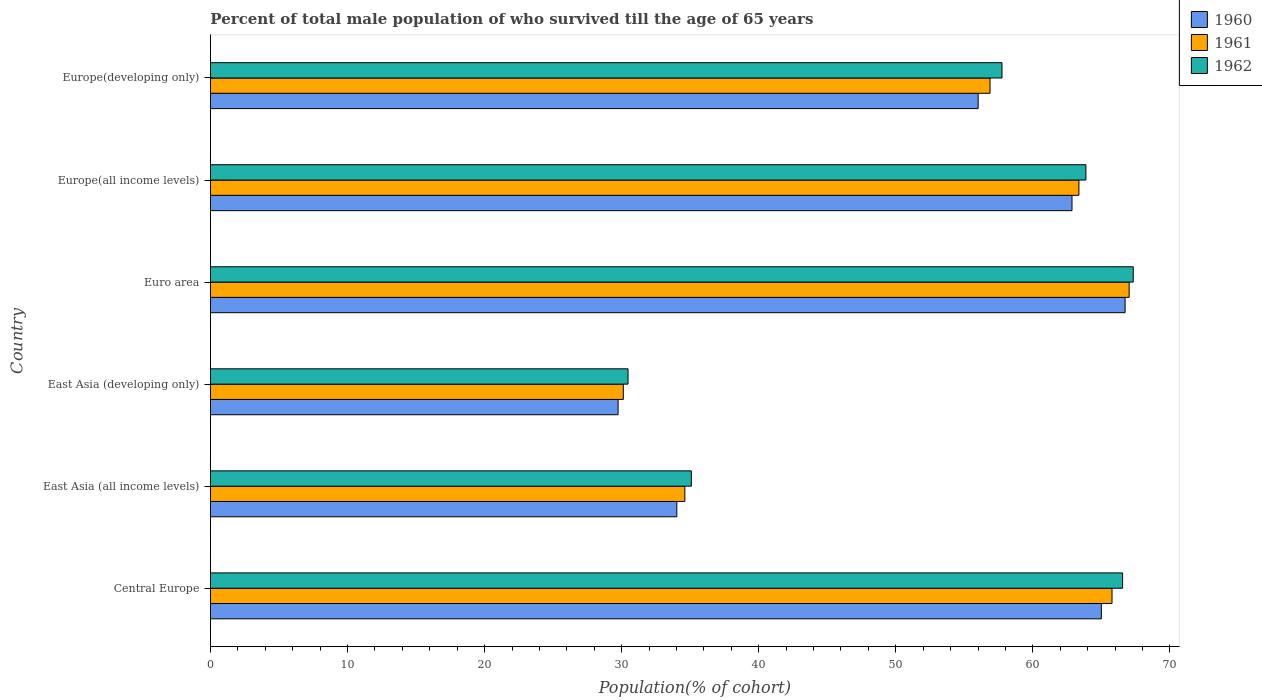How many different coloured bars are there?
Provide a short and direct response. 3. How many bars are there on the 2nd tick from the top?
Make the answer very short. 3. What is the label of the 4th group of bars from the top?
Your answer should be compact. East Asia (developing only). What is the percentage of total male population who survived till the age of 65 years in 1962 in East Asia (all income levels)?
Give a very brief answer. 35.08. Across all countries, what is the maximum percentage of total male population who survived till the age of 65 years in 1960?
Provide a short and direct response. 66.73. Across all countries, what is the minimum percentage of total male population who survived till the age of 65 years in 1962?
Your answer should be compact. 30.46. In which country was the percentage of total male population who survived till the age of 65 years in 1961 maximum?
Your answer should be compact. Euro area. In which country was the percentage of total male population who survived till the age of 65 years in 1961 minimum?
Make the answer very short. East Asia (developing only). What is the total percentage of total male population who survived till the age of 65 years in 1962 in the graph?
Offer a terse response. 321.03. What is the difference between the percentage of total male population who survived till the age of 65 years in 1962 in East Asia (all income levels) and that in Europe(developing only)?
Ensure brevity in your answer.  -22.67. What is the difference between the percentage of total male population who survived till the age of 65 years in 1962 in Europe(developing only) and the percentage of total male population who survived till the age of 65 years in 1960 in East Asia (developing only)?
Your answer should be compact. 28.01. What is the average percentage of total male population who survived till the age of 65 years in 1961 per country?
Provide a short and direct response. 52.96. What is the difference between the percentage of total male population who survived till the age of 65 years in 1960 and percentage of total male population who survived till the age of 65 years in 1961 in Euro area?
Provide a short and direct response. -0.3. In how many countries, is the percentage of total male population who survived till the age of 65 years in 1962 greater than 62 %?
Give a very brief answer. 3. What is the ratio of the percentage of total male population who survived till the age of 65 years in 1962 in Central Europe to that in Euro area?
Give a very brief answer. 0.99. Is the difference between the percentage of total male population who survived till the age of 65 years in 1960 in Euro area and Europe(developing only) greater than the difference between the percentage of total male population who survived till the age of 65 years in 1961 in Euro area and Europe(developing only)?
Keep it short and to the point. Yes. What is the difference between the highest and the second highest percentage of total male population who survived till the age of 65 years in 1962?
Offer a very short reply. 0.77. What is the difference between the highest and the lowest percentage of total male population who survived till the age of 65 years in 1960?
Give a very brief answer. 36.99. Is it the case that in every country, the sum of the percentage of total male population who survived till the age of 65 years in 1960 and percentage of total male population who survived till the age of 65 years in 1961 is greater than the percentage of total male population who survived till the age of 65 years in 1962?
Your answer should be compact. Yes. Are all the bars in the graph horizontal?
Offer a very short reply. Yes. How many countries are there in the graph?
Give a very brief answer. 6. How are the legend labels stacked?
Offer a terse response. Vertical. What is the title of the graph?
Make the answer very short. Percent of total male population of who survived till the age of 65 years. What is the label or title of the X-axis?
Provide a succinct answer. Population(% of cohort). What is the label or title of the Y-axis?
Provide a succinct answer. Country. What is the Population(% of cohort) of 1960 in Central Europe?
Provide a short and direct response. 65. What is the Population(% of cohort) of 1961 in Central Europe?
Offer a very short reply. 65.77. What is the Population(% of cohort) in 1962 in Central Europe?
Keep it short and to the point. 66.55. What is the Population(% of cohort) of 1960 in East Asia (all income levels)?
Make the answer very short. 34.02. What is the Population(% of cohort) in 1961 in East Asia (all income levels)?
Provide a succinct answer. 34.61. What is the Population(% of cohort) in 1962 in East Asia (all income levels)?
Offer a terse response. 35.08. What is the Population(% of cohort) of 1960 in East Asia (developing only)?
Make the answer very short. 29.74. What is the Population(% of cohort) in 1961 in East Asia (developing only)?
Keep it short and to the point. 30.12. What is the Population(% of cohort) of 1962 in East Asia (developing only)?
Give a very brief answer. 30.46. What is the Population(% of cohort) of 1960 in Euro area?
Offer a very short reply. 66.73. What is the Population(% of cohort) of 1961 in Euro area?
Give a very brief answer. 67.03. What is the Population(% of cohort) in 1962 in Euro area?
Provide a short and direct response. 67.32. What is the Population(% of cohort) in 1960 in Europe(all income levels)?
Provide a succinct answer. 62.85. What is the Population(% of cohort) in 1961 in Europe(all income levels)?
Offer a terse response. 63.36. What is the Population(% of cohort) in 1962 in Europe(all income levels)?
Your answer should be compact. 63.87. What is the Population(% of cohort) of 1960 in Europe(developing only)?
Give a very brief answer. 56.01. What is the Population(% of cohort) in 1961 in Europe(developing only)?
Your response must be concise. 56.88. What is the Population(% of cohort) of 1962 in Europe(developing only)?
Your response must be concise. 57.75. Across all countries, what is the maximum Population(% of cohort) of 1960?
Provide a short and direct response. 66.73. Across all countries, what is the maximum Population(% of cohort) of 1961?
Give a very brief answer. 67.03. Across all countries, what is the maximum Population(% of cohort) of 1962?
Give a very brief answer. 67.32. Across all countries, what is the minimum Population(% of cohort) in 1960?
Make the answer very short. 29.74. Across all countries, what is the minimum Population(% of cohort) in 1961?
Make the answer very short. 30.12. Across all countries, what is the minimum Population(% of cohort) in 1962?
Make the answer very short. 30.46. What is the total Population(% of cohort) in 1960 in the graph?
Your response must be concise. 314.35. What is the total Population(% of cohort) of 1961 in the graph?
Make the answer very short. 317.76. What is the total Population(% of cohort) in 1962 in the graph?
Provide a succinct answer. 321.03. What is the difference between the Population(% of cohort) of 1960 in Central Europe and that in East Asia (all income levels)?
Keep it short and to the point. 30.97. What is the difference between the Population(% of cohort) of 1961 in Central Europe and that in East Asia (all income levels)?
Offer a terse response. 31.17. What is the difference between the Population(% of cohort) of 1962 in Central Europe and that in East Asia (all income levels)?
Provide a short and direct response. 31.47. What is the difference between the Population(% of cohort) of 1960 in Central Europe and that in East Asia (developing only)?
Provide a short and direct response. 35.26. What is the difference between the Population(% of cohort) of 1961 in Central Europe and that in East Asia (developing only)?
Give a very brief answer. 35.65. What is the difference between the Population(% of cohort) of 1962 in Central Europe and that in East Asia (developing only)?
Your response must be concise. 36.08. What is the difference between the Population(% of cohort) in 1960 in Central Europe and that in Euro area?
Offer a very short reply. -1.73. What is the difference between the Population(% of cohort) of 1961 in Central Europe and that in Euro area?
Offer a very short reply. -1.25. What is the difference between the Population(% of cohort) of 1962 in Central Europe and that in Euro area?
Your response must be concise. -0.77. What is the difference between the Population(% of cohort) in 1960 in Central Europe and that in Europe(all income levels)?
Make the answer very short. 2.14. What is the difference between the Population(% of cohort) in 1961 in Central Europe and that in Europe(all income levels)?
Offer a very short reply. 2.41. What is the difference between the Population(% of cohort) in 1962 in Central Europe and that in Europe(all income levels)?
Provide a short and direct response. 2.68. What is the difference between the Population(% of cohort) in 1960 in Central Europe and that in Europe(developing only)?
Your answer should be compact. 8.99. What is the difference between the Population(% of cohort) of 1961 in Central Europe and that in Europe(developing only)?
Your response must be concise. 8.9. What is the difference between the Population(% of cohort) in 1962 in Central Europe and that in Europe(developing only)?
Keep it short and to the point. 8.8. What is the difference between the Population(% of cohort) in 1960 in East Asia (all income levels) and that in East Asia (developing only)?
Your response must be concise. 4.28. What is the difference between the Population(% of cohort) of 1961 in East Asia (all income levels) and that in East Asia (developing only)?
Keep it short and to the point. 4.49. What is the difference between the Population(% of cohort) of 1962 in East Asia (all income levels) and that in East Asia (developing only)?
Your response must be concise. 4.62. What is the difference between the Population(% of cohort) in 1960 in East Asia (all income levels) and that in Euro area?
Offer a very short reply. -32.71. What is the difference between the Population(% of cohort) in 1961 in East Asia (all income levels) and that in Euro area?
Offer a very short reply. -32.42. What is the difference between the Population(% of cohort) of 1962 in East Asia (all income levels) and that in Euro area?
Provide a succinct answer. -32.24. What is the difference between the Population(% of cohort) of 1960 in East Asia (all income levels) and that in Europe(all income levels)?
Your answer should be compact. -28.83. What is the difference between the Population(% of cohort) in 1961 in East Asia (all income levels) and that in Europe(all income levels)?
Your answer should be compact. -28.75. What is the difference between the Population(% of cohort) of 1962 in East Asia (all income levels) and that in Europe(all income levels)?
Provide a succinct answer. -28.79. What is the difference between the Population(% of cohort) of 1960 in East Asia (all income levels) and that in Europe(developing only)?
Keep it short and to the point. -21.98. What is the difference between the Population(% of cohort) of 1961 in East Asia (all income levels) and that in Europe(developing only)?
Your response must be concise. -22.27. What is the difference between the Population(% of cohort) of 1962 in East Asia (all income levels) and that in Europe(developing only)?
Your response must be concise. -22.67. What is the difference between the Population(% of cohort) of 1960 in East Asia (developing only) and that in Euro area?
Offer a very short reply. -36.99. What is the difference between the Population(% of cohort) in 1961 in East Asia (developing only) and that in Euro area?
Keep it short and to the point. -36.9. What is the difference between the Population(% of cohort) in 1962 in East Asia (developing only) and that in Euro area?
Provide a succinct answer. -36.86. What is the difference between the Population(% of cohort) in 1960 in East Asia (developing only) and that in Europe(all income levels)?
Make the answer very short. -33.12. What is the difference between the Population(% of cohort) of 1961 in East Asia (developing only) and that in Europe(all income levels)?
Provide a succinct answer. -33.24. What is the difference between the Population(% of cohort) of 1962 in East Asia (developing only) and that in Europe(all income levels)?
Your answer should be very brief. -33.4. What is the difference between the Population(% of cohort) in 1960 in East Asia (developing only) and that in Europe(developing only)?
Give a very brief answer. -26.27. What is the difference between the Population(% of cohort) of 1961 in East Asia (developing only) and that in Europe(developing only)?
Your response must be concise. -26.75. What is the difference between the Population(% of cohort) in 1962 in East Asia (developing only) and that in Europe(developing only)?
Offer a very short reply. -27.28. What is the difference between the Population(% of cohort) of 1960 in Euro area and that in Europe(all income levels)?
Your answer should be compact. 3.87. What is the difference between the Population(% of cohort) of 1961 in Euro area and that in Europe(all income levels)?
Offer a very short reply. 3.67. What is the difference between the Population(% of cohort) in 1962 in Euro area and that in Europe(all income levels)?
Your answer should be very brief. 3.45. What is the difference between the Population(% of cohort) in 1960 in Euro area and that in Europe(developing only)?
Keep it short and to the point. 10.72. What is the difference between the Population(% of cohort) in 1961 in Euro area and that in Europe(developing only)?
Make the answer very short. 10.15. What is the difference between the Population(% of cohort) of 1962 in Euro area and that in Europe(developing only)?
Keep it short and to the point. 9.57. What is the difference between the Population(% of cohort) of 1960 in Europe(all income levels) and that in Europe(developing only)?
Your response must be concise. 6.85. What is the difference between the Population(% of cohort) in 1961 in Europe(all income levels) and that in Europe(developing only)?
Your answer should be compact. 6.49. What is the difference between the Population(% of cohort) in 1962 in Europe(all income levels) and that in Europe(developing only)?
Your answer should be very brief. 6.12. What is the difference between the Population(% of cohort) of 1960 in Central Europe and the Population(% of cohort) of 1961 in East Asia (all income levels)?
Ensure brevity in your answer.  30.39. What is the difference between the Population(% of cohort) in 1960 in Central Europe and the Population(% of cohort) in 1962 in East Asia (all income levels)?
Keep it short and to the point. 29.91. What is the difference between the Population(% of cohort) of 1961 in Central Europe and the Population(% of cohort) of 1962 in East Asia (all income levels)?
Provide a succinct answer. 30.69. What is the difference between the Population(% of cohort) in 1960 in Central Europe and the Population(% of cohort) in 1961 in East Asia (developing only)?
Your answer should be very brief. 34.87. What is the difference between the Population(% of cohort) in 1960 in Central Europe and the Population(% of cohort) in 1962 in East Asia (developing only)?
Your answer should be very brief. 34.53. What is the difference between the Population(% of cohort) in 1961 in Central Europe and the Population(% of cohort) in 1962 in East Asia (developing only)?
Ensure brevity in your answer.  35.31. What is the difference between the Population(% of cohort) of 1960 in Central Europe and the Population(% of cohort) of 1961 in Euro area?
Provide a short and direct response. -2.03. What is the difference between the Population(% of cohort) of 1960 in Central Europe and the Population(% of cohort) of 1962 in Euro area?
Your answer should be very brief. -2.33. What is the difference between the Population(% of cohort) of 1961 in Central Europe and the Population(% of cohort) of 1962 in Euro area?
Provide a short and direct response. -1.55. What is the difference between the Population(% of cohort) of 1960 in Central Europe and the Population(% of cohort) of 1961 in Europe(all income levels)?
Your answer should be very brief. 1.64. What is the difference between the Population(% of cohort) in 1960 in Central Europe and the Population(% of cohort) in 1962 in Europe(all income levels)?
Provide a succinct answer. 1.13. What is the difference between the Population(% of cohort) of 1961 in Central Europe and the Population(% of cohort) of 1962 in Europe(all income levels)?
Ensure brevity in your answer.  1.91. What is the difference between the Population(% of cohort) in 1960 in Central Europe and the Population(% of cohort) in 1961 in Europe(developing only)?
Ensure brevity in your answer.  8.12. What is the difference between the Population(% of cohort) of 1960 in Central Europe and the Population(% of cohort) of 1962 in Europe(developing only)?
Offer a terse response. 7.25. What is the difference between the Population(% of cohort) in 1961 in Central Europe and the Population(% of cohort) in 1962 in Europe(developing only)?
Ensure brevity in your answer.  8.03. What is the difference between the Population(% of cohort) in 1960 in East Asia (all income levels) and the Population(% of cohort) in 1961 in East Asia (developing only)?
Make the answer very short. 3.9. What is the difference between the Population(% of cohort) of 1960 in East Asia (all income levels) and the Population(% of cohort) of 1962 in East Asia (developing only)?
Keep it short and to the point. 3.56. What is the difference between the Population(% of cohort) of 1961 in East Asia (all income levels) and the Population(% of cohort) of 1962 in East Asia (developing only)?
Your answer should be very brief. 4.14. What is the difference between the Population(% of cohort) in 1960 in East Asia (all income levels) and the Population(% of cohort) in 1961 in Euro area?
Provide a succinct answer. -33. What is the difference between the Population(% of cohort) of 1960 in East Asia (all income levels) and the Population(% of cohort) of 1962 in Euro area?
Give a very brief answer. -33.3. What is the difference between the Population(% of cohort) in 1961 in East Asia (all income levels) and the Population(% of cohort) in 1962 in Euro area?
Provide a short and direct response. -32.71. What is the difference between the Population(% of cohort) in 1960 in East Asia (all income levels) and the Population(% of cohort) in 1961 in Europe(all income levels)?
Make the answer very short. -29.34. What is the difference between the Population(% of cohort) in 1960 in East Asia (all income levels) and the Population(% of cohort) in 1962 in Europe(all income levels)?
Offer a terse response. -29.85. What is the difference between the Population(% of cohort) of 1961 in East Asia (all income levels) and the Population(% of cohort) of 1962 in Europe(all income levels)?
Ensure brevity in your answer.  -29.26. What is the difference between the Population(% of cohort) of 1960 in East Asia (all income levels) and the Population(% of cohort) of 1961 in Europe(developing only)?
Your response must be concise. -22.85. What is the difference between the Population(% of cohort) in 1960 in East Asia (all income levels) and the Population(% of cohort) in 1962 in Europe(developing only)?
Give a very brief answer. -23.72. What is the difference between the Population(% of cohort) in 1961 in East Asia (all income levels) and the Population(% of cohort) in 1962 in Europe(developing only)?
Your answer should be very brief. -23.14. What is the difference between the Population(% of cohort) in 1960 in East Asia (developing only) and the Population(% of cohort) in 1961 in Euro area?
Your response must be concise. -37.29. What is the difference between the Population(% of cohort) in 1960 in East Asia (developing only) and the Population(% of cohort) in 1962 in Euro area?
Make the answer very short. -37.58. What is the difference between the Population(% of cohort) in 1961 in East Asia (developing only) and the Population(% of cohort) in 1962 in Euro area?
Give a very brief answer. -37.2. What is the difference between the Population(% of cohort) of 1960 in East Asia (developing only) and the Population(% of cohort) of 1961 in Europe(all income levels)?
Provide a short and direct response. -33.62. What is the difference between the Population(% of cohort) of 1960 in East Asia (developing only) and the Population(% of cohort) of 1962 in Europe(all income levels)?
Provide a succinct answer. -34.13. What is the difference between the Population(% of cohort) in 1961 in East Asia (developing only) and the Population(% of cohort) in 1962 in Europe(all income levels)?
Provide a succinct answer. -33.75. What is the difference between the Population(% of cohort) of 1960 in East Asia (developing only) and the Population(% of cohort) of 1961 in Europe(developing only)?
Your response must be concise. -27.14. What is the difference between the Population(% of cohort) in 1960 in East Asia (developing only) and the Population(% of cohort) in 1962 in Europe(developing only)?
Ensure brevity in your answer.  -28.01. What is the difference between the Population(% of cohort) of 1961 in East Asia (developing only) and the Population(% of cohort) of 1962 in Europe(developing only)?
Keep it short and to the point. -27.63. What is the difference between the Population(% of cohort) of 1960 in Euro area and the Population(% of cohort) of 1961 in Europe(all income levels)?
Offer a terse response. 3.37. What is the difference between the Population(% of cohort) of 1960 in Euro area and the Population(% of cohort) of 1962 in Europe(all income levels)?
Your answer should be compact. 2.86. What is the difference between the Population(% of cohort) in 1961 in Euro area and the Population(% of cohort) in 1962 in Europe(all income levels)?
Offer a terse response. 3.16. What is the difference between the Population(% of cohort) of 1960 in Euro area and the Population(% of cohort) of 1961 in Europe(developing only)?
Your answer should be very brief. 9.85. What is the difference between the Population(% of cohort) of 1960 in Euro area and the Population(% of cohort) of 1962 in Europe(developing only)?
Your response must be concise. 8.98. What is the difference between the Population(% of cohort) in 1961 in Euro area and the Population(% of cohort) in 1962 in Europe(developing only)?
Provide a succinct answer. 9.28. What is the difference between the Population(% of cohort) in 1960 in Europe(all income levels) and the Population(% of cohort) in 1961 in Europe(developing only)?
Your response must be concise. 5.98. What is the difference between the Population(% of cohort) in 1960 in Europe(all income levels) and the Population(% of cohort) in 1962 in Europe(developing only)?
Your answer should be compact. 5.11. What is the difference between the Population(% of cohort) of 1961 in Europe(all income levels) and the Population(% of cohort) of 1962 in Europe(developing only)?
Keep it short and to the point. 5.61. What is the average Population(% of cohort) of 1960 per country?
Offer a terse response. 52.39. What is the average Population(% of cohort) of 1961 per country?
Provide a short and direct response. 52.96. What is the average Population(% of cohort) in 1962 per country?
Give a very brief answer. 53.51. What is the difference between the Population(% of cohort) of 1960 and Population(% of cohort) of 1961 in Central Europe?
Offer a very short reply. -0.78. What is the difference between the Population(% of cohort) of 1960 and Population(% of cohort) of 1962 in Central Europe?
Make the answer very short. -1.55. What is the difference between the Population(% of cohort) of 1961 and Population(% of cohort) of 1962 in Central Europe?
Provide a short and direct response. -0.77. What is the difference between the Population(% of cohort) of 1960 and Population(% of cohort) of 1961 in East Asia (all income levels)?
Make the answer very short. -0.59. What is the difference between the Population(% of cohort) in 1960 and Population(% of cohort) in 1962 in East Asia (all income levels)?
Ensure brevity in your answer.  -1.06. What is the difference between the Population(% of cohort) of 1961 and Population(% of cohort) of 1962 in East Asia (all income levels)?
Offer a very short reply. -0.47. What is the difference between the Population(% of cohort) of 1960 and Population(% of cohort) of 1961 in East Asia (developing only)?
Give a very brief answer. -0.38. What is the difference between the Population(% of cohort) in 1960 and Population(% of cohort) in 1962 in East Asia (developing only)?
Provide a short and direct response. -0.73. What is the difference between the Population(% of cohort) of 1961 and Population(% of cohort) of 1962 in East Asia (developing only)?
Provide a succinct answer. -0.34. What is the difference between the Population(% of cohort) in 1960 and Population(% of cohort) in 1961 in Euro area?
Offer a terse response. -0.3. What is the difference between the Population(% of cohort) in 1960 and Population(% of cohort) in 1962 in Euro area?
Provide a short and direct response. -0.59. What is the difference between the Population(% of cohort) of 1961 and Population(% of cohort) of 1962 in Euro area?
Provide a short and direct response. -0.3. What is the difference between the Population(% of cohort) of 1960 and Population(% of cohort) of 1961 in Europe(all income levels)?
Provide a succinct answer. -0.51. What is the difference between the Population(% of cohort) in 1960 and Population(% of cohort) in 1962 in Europe(all income levels)?
Your answer should be very brief. -1.01. What is the difference between the Population(% of cohort) in 1961 and Population(% of cohort) in 1962 in Europe(all income levels)?
Make the answer very short. -0.51. What is the difference between the Population(% of cohort) in 1960 and Population(% of cohort) in 1961 in Europe(developing only)?
Provide a short and direct response. -0.87. What is the difference between the Population(% of cohort) of 1960 and Population(% of cohort) of 1962 in Europe(developing only)?
Give a very brief answer. -1.74. What is the difference between the Population(% of cohort) in 1961 and Population(% of cohort) in 1962 in Europe(developing only)?
Offer a very short reply. -0.87. What is the ratio of the Population(% of cohort) of 1960 in Central Europe to that in East Asia (all income levels)?
Provide a succinct answer. 1.91. What is the ratio of the Population(% of cohort) in 1961 in Central Europe to that in East Asia (all income levels)?
Give a very brief answer. 1.9. What is the ratio of the Population(% of cohort) of 1962 in Central Europe to that in East Asia (all income levels)?
Your answer should be compact. 1.9. What is the ratio of the Population(% of cohort) in 1960 in Central Europe to that in East Asia (developing only)?
Give a very brief answer. 2.19. What is the ratio of the Population(% of cohort) of 1961 in Central Europe to that in East Asia (developing only)?
Your answer should be very brief. 2.18. What is the ratio of the Population(% of cohort) in 1962 in Central Europe to that in East Asia (developing only)?
Give a very brief answer. 2.18. What is the ratio of the Population(% of cohort) in 1960 in Central Europe to that in Euro area?
Your answer should be very brief. 0.97. What is the ratio of the Population(% of cohort) in 1961 in Central Europe to that in Euro area?
Your answer should be very brief. 0.98. What is the ratio of the Population(% of cohort) of 1962 in Central Europe to that in Euro area?
Your answer should be very brief. 0.99. What is the ratio of the Population(% of cohort) of 1960 in Central Europe to that in Europe(all income levels)?
Offer a very short reply. 1.03. What is the ratio of the Population(% of cohort) in 1961 in Central Europe to that in Europe(all income levels)?
Offer a very short reply. 1.04. What is the ratio of the Population(% of cohort) in 1962 in Central Europe to that in Europe(all income levels)?
Give a very brief answer. 1.04. What is the ratio of the Population(% of cohort) of 1960 in Central Europe to that in Europe(developing only)?
Provide a short and direct response. 1.16. What is the ratio of the Population(% of cohort) of 1961 in Central Europe to that in Europe(developing only)?
Give a very brief answer. 1.16. What is the ratio of the Population(% of cohort) in 1962 in Central Europe to that in Europe(developing only)?
Your answer should be compact. 1.15. What is the ratio of the Population(% of cohort) of 1960 in East Asia (all income levels) to that in East Asia (developing only)?
Ensure brevity in your answer.  1.14. What is the ratio of the Population(% of cohort) of 1961 in East Asia (all income levels) to that in East Asia (developing only)?
Your answer should be compact. 1.15. What is the ratio of the Population(% of cohort) of 1962 in East Asia (all income levels) to that in East Asia (developing only)?
Provide a succinct answer. 1.15. What is the ratio of the Population(% of cohort) in 1960 in East Asia (all income levels) to that in Euro area?
Ensure brevity in your answer.  0.51. What is the ratio of the Population(% of cohort) in 1961 in East Asia (all income levels) to that in Euro area?
Your answer should be very brief. 0.52. What is the ratio of the Population(% of cohort) of 1962 in East Asia (all income levels) to that in Euro area?
Offer a very short reply. 0.52. What is the ratio of the Population(% of cohort) of 1960 in East Asia (all income levels) to that in Europe(all income levels)?
Make the answer very short. 0.54. What is the ratio of the Population(% of cohort) of 1961 in East Asia (all income levels) to that in Europe(all income levels)?
Ensure brevity in your answer.  0.55. What is the ratio of the Population(% of cohort) in 1962 in East Asia (all income levels) to that in Europe(all income levels)?
Make the answer very short. 0.55. What is the ratio of the Population(% of cohort) in 1960 in East Asia (all income levels) to that in Europe(developing only)?
Provide a short and direct response. 0.61. What is the ratio of the Population(% of cohort) of 1961 in East Asia (all income levels) to that in Europe(developing only)?
Your answer should be very brief. 0.61. What is the ratio of the Population(% of cohort) of 1962 in East Asia (all income levels) to that in Europe(developing only)?
Provide a succinct answer. 0.61. What is the ratio of the Population(% of cohort) in 1960 in East Asia (developing only) to that in Euro area?
Make the answer very short. 0.45. What is the ratio of the Population(% of cohort) of 1961 in East Asia (developing only) to that in Euro area?
Ensure brevity in your answer.  0.45. What is the ratio of the Population(% of cohort) in 1962 in East Asia (developing only) to that in Euro area?
Your response must be concise. 0.45. What is the ratio of the Population(% of cohort) in 1960 in East Asia (developing only) to that in Europe(all income levels)?
Your answer should be very brief. 0.47. What is the ratio of the Population(% of cohort) in 1961 in East Asia (developing only) to that in Europe(all income levels)?
Your answer should be compact. 0.48. What is the ratio of the Population(% of cohort) in 1962 in East Asia (developing only) to that in Europe(all income levels)?
Make the answer very short. 0.48. What is the ratio of the Population(% of cohort) of 1960 in East Asia (developing only) to that in Europe(developing only)?
Offer a very short reply. 0.53. What is the ratio of the Population(% of cohort) in 1961 in East Asia (developing only) to that in Europe(developing only)?
Keep it short and to the point. 0.53. What is the ratio of the Population(% of cohort) of 1962 in East Asia (developing only) to that in Europe(developing only)?
Your answer should be compact. 0.53. What is the ratio of the Population(% of cohort) in 1960 in Euro area to that in Europe(all income levels)?
Give a very brief answer. 1.06. What is the ratio of the Population(% of cohort) of 1961 in Euro area to that in Europe(all income levels)?
Keep it short and to the point. 1.06. What is the ratio of the Population(% of cohort) in 1962 in Euro area to that in Europe(all income levels)?
Your answer should be very brief. 1.05. What is the ratio of the Population(% of cohort) of 1960 in Euro area to that in Europe(developing only)?
Give a very brief answer. 1.19. What is the ratio of the Population(% of cohort) of 1961 in Euro area to that in Europe(developing only)?
Keep it short and to the point. 1.18. What is the ratio of the Population(% of cohort) in 1962 in Euro area to that in Europe(developing only)?
Provide a short and direct response. 1.17. What is the ratio of the Population(% of cohort) of 1960 in Europe(all income levels) to that in Europe(developing only)?
Give a very brief answer. 1.12. What is the ratio of the Population(% of cohort) of 1961 in Europe(all income levels) to that in Europe(developing only)?
Provide a succinct answer. 1.11. What is the ratio of the Population(% of cohort) in 1962 in Europe(all income levels) to that in Europe(developing only)?
Your response must be concise. 1.11. What is the difference between the highest and the second highest Population(% of cohort) of 1960?
Offer a terse response. 1.73. What is the difference between the highest and the second highest Population(% of cohort) of 1961?
Offer a very short reply. 1.25. What is the difference between the highest and the second highest Population(% of cohort) of 1962?
Your answer should be compact. 0.77. What is the difference between the highest and the lowest Population(% of cohort) of 1960?
Your response must be concise. 36.99. What is the difference between the highest and the lowest Population(% of cohort) in 1961?
Ensure brevity in your answer.  36.9. What is the difference between the highest and the lowest Population(% of cohort) of 1962?
Offer a terse response. 36.86. 